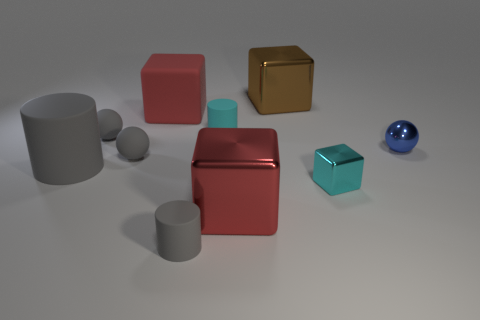Subtract all spheres. How many objects are left? 7 Subtract all yellow metal objects. Subtract all small gray rubber cylinders. How many objects are left? 9 Add 6 big brown metallic cubes. How many big brown metallic cubes are left? 7 Add 4 large cyan matte objects. How many large cyan matte objects exist? 4 Subtract 1 gray cylinders. How many objects are left? 9 